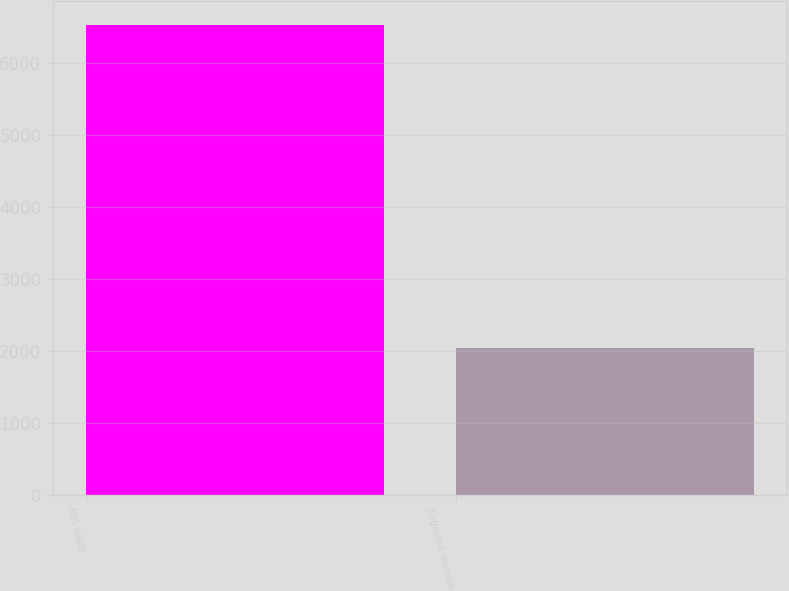Convert chart. <chart><loc_0><loc_0><loc_500><loc_500><bar_chart><fcel>Net sales<fcel>Segment income<nl><fcel>6533<fcel>2041<nl></chart> 